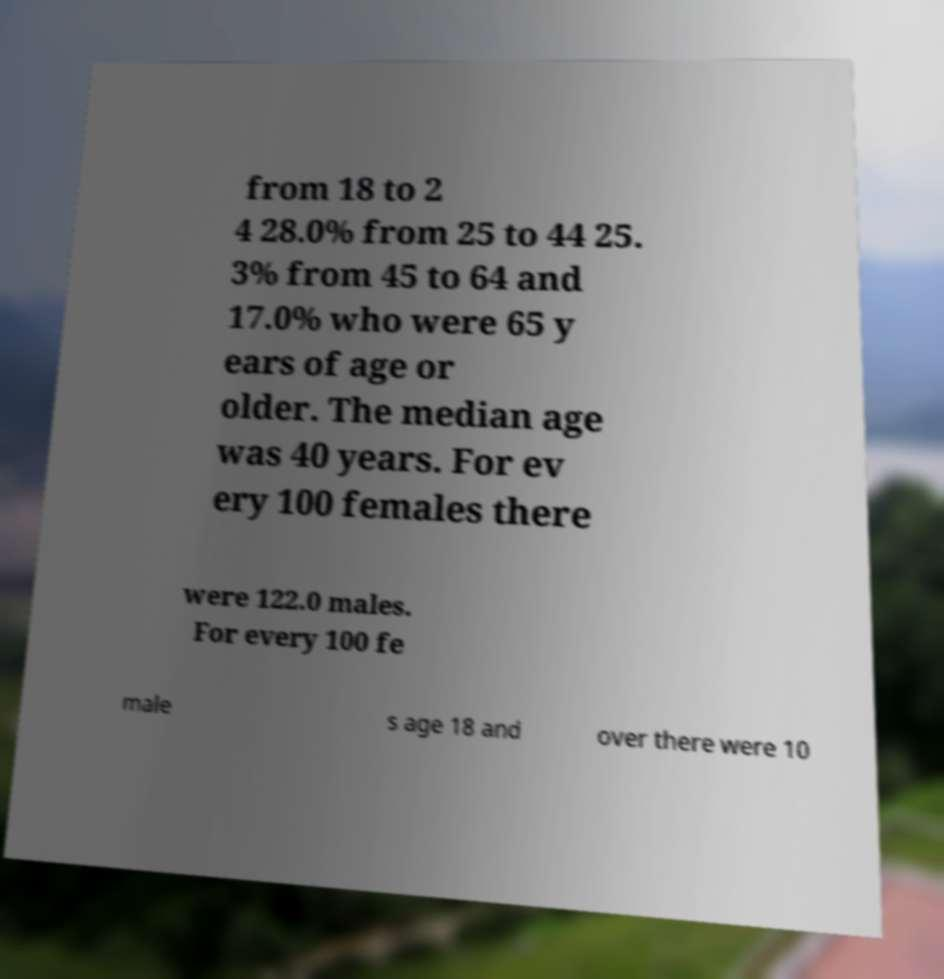Can you accurately transcribe the text from the provided image for me? from 18 to 2 4 28.0% from 25 to 44 25. 3% from 45 to 64 and 17.0% who were 65 y ears of age or older. The median age was 40 years. For ev ery 100 females there were 122.0 males. For every 100 fe male s age 18 and over there were 10 